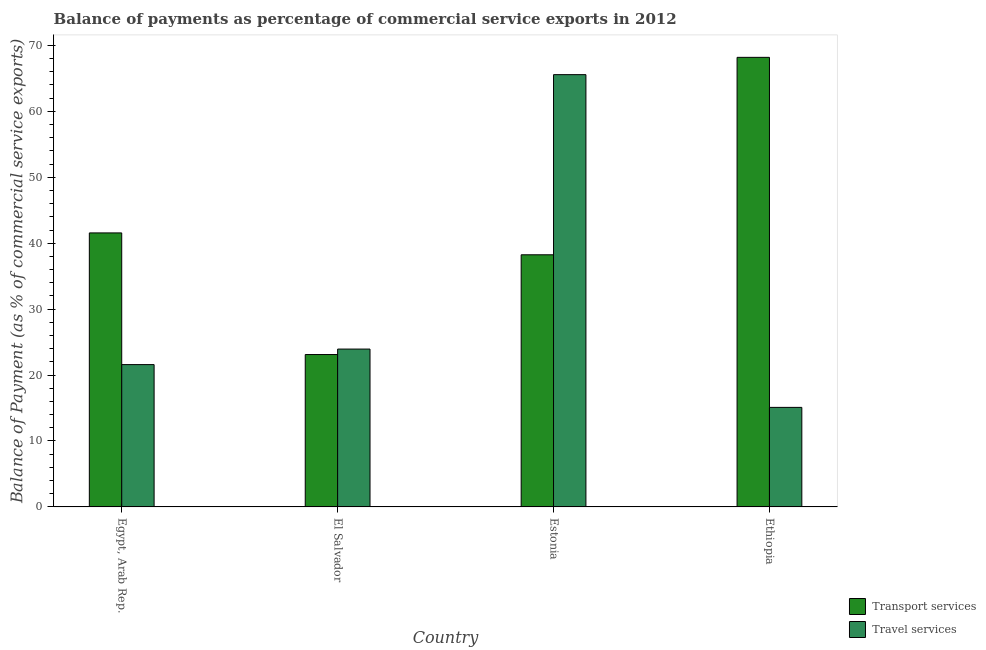How many different coloured bars are there?
Your response must be concise. 2. Are the number of bars on each tick of the X-axis equal?
Your response must be concise. Yes. How many bars are there on the 2nd tick from the left?
Offer a very short reply. 2. What is the label of the 4th group of bars from the left?
Provide a short and direct response. Ethiopia. In how many cases, is the number of bars for a given country not equal to the number of legend labels?
Offer a terse response. 0. What is the balance of payments of travel services in Estonia?
Make the answer very short. 65.56. Across all countries, what is the maximum balance of payments of travel services?
Offer a terse response. 65.56. Across all countries, what is the minimum balance of payments of transport services?
Provide a succinct answer. 23.11. In which country was the balance of payments of travel services maximum?
Your answer should be compact. Estonia. In which country was the balance of payments of travel services minimum?
Provide a short and direct response. Ethiopia. What is the total balance of payments of travel services in the graph?
Your response must be concise. 126.19. What is the difference between the balance of payments of transport services in El Salvador and that in Ethiopia?
Ensure brevity in your answer.  -45.07. What is the difference between the balance of payments of travel services in El Salvador and the balance of payments of transport services in Egypt, Arab Rep.?
Ensure brevity in your answer.  -17.62. What is the average balance of payments of transport services per country?
Provide a succinct answer. 42.77. What is the difference between the balance of payments of transport services and balance of payments of travel services in Estonia?
Your answer should be compact. -27.32. What is the ratio of the balance of payments of transport services in Egypt, Arab Rep. to that in Estonia?
Your answer should be compact. 1.09. Is the balance of payments of travel services in Egypt, Arab Rep. less than that in Estonia?
Give a very brief answer. Yes. What is the difference between the highest and the second highest balance of payments of travel services?
Provide a short and direct response. 41.62. What is the difference between the highest and the lowest balance of payments of transport services?
Make the answer very short. 45.07. What does the 2nd bar from the left in Estonia represents?
Your answer should be very brief. Travel services. What does the 2nd bar from the right in Egypt, Arab Rep. represents?
Provide a succinct answer. Transport services. How many bars are there?
Your answer should be very brief. 8. Are all the bars in the graph horizontal?
Make the answer very short. No. What is the difference between two consecutive major ticks on the Y-axis?
Offer a terse response. 10. Are the values on the major ticks of Y-axis written in scientific E-notation?
Your answer should be compact. No. Does the graph contain any zero values?
Your answer should be very brief. No. Does the graph contain grids?
Make the answer very short. No. How are the legend labels stacked?
Your answer should be compact. Vertical. What is the title of the graph?
Make the answer very short. Balance of payments as percentage of commercial service exports in 2012. What is the label or title of the Y-axis?
Make the answer very short. Balance of Payment (as % of commercial service exports). What is the Balance of Payment (as % of commercial service exports) of Transport services in Egypt, Arab Rep.?
Provide a succinct answer. 41.56. What is the Balance of Payment (as % of commercial service exports) of Travel services in Egypt, Arab Rep.?
Give a very brief answer. 21.59. What is the Balance of Payment (as % of commercial service exports) in Transport services in El Salvador?
Offer a terse response. 23.11. What is the Balance of Payment (as % of commercial service exports) in Travel services in El Salvador?
Provide a succinct answer. 23.94. What is the Balance of Payment (as % of commercial service exports) of Transport services in Estonia?
Offer a terse response. 38.24. What is the Balance of Payment (as % of commercial service exports) in Travel services in Estonia?
Your response must be concise. 65.56. What is the Balance of Payment (as % of commercial service exports) of Transport services in Ethiopia?
Your response must be concise. 68.18. What is the Balance of Payment (as % of commercial service exports) in Travel services in Ethiopia?
Your answer should be very brief. 15.1. Across all countries, what is the maximum Balance of Payment (as % of commercial service exports) in Transport services?
Make the answer very short. 68.18. Across all countries, what is the maximum Balance of Payment (as % of commercial service exports) in Travel services?
Your response must be concise. 65.56. Across all countries, what is the minimum Balance of Payment (as % of commercial service exports) of Transport services?
Keep it short and to the point. 23.11. Across all countries, what is the minimum Balance of Payment (as % of commercial service exports) in Travel services?
Make the answer very short. 15.1. What is the total Balance of Payment (as % of commercial service exports) in Transport services in the graph?
Offer a terse response. 171.1. What is the total Balance of Payment (as % of commercial service exports) of Travel services in the graph?
Offer a terse response. 126.19. What is the difference between the Balance of Payment (as % of commercial service exports) of Transport services in Egypt, Arab Rep. and that in El Salvador?
Provide a short and direct response. 18.45. What is the difference between the Balance of Payment (as % of commercial service exports) in Travel services in Egypt, Arab Rep. and that in El Salvador?
Make the answer very short. -2.35. What is the difference between the Balance of Payment (as % of commercial service exports) of Transport services in Egypt, Arab Rep. and that in Estonia?
Ensure brevity in your answer.  3.32. What is the difference between the Balance of Payment (as % of commercial service exports) of Travel services in Egypt, Arab Rep. and that in Estonia?
Provide a succinct answer. -43.98. What is the difference between the Balance of Payment (as % of commercial service exports) of Transport services in Egypt, Arab Rep. and that in Ethiopia?
Keep it short and to the point. -26.63. What is the difference between the Balance of Payment (as % of commercial service exports) in Travel services in Egypt, Arab Rep. and that in Ethiopia?
Provide a short and direct response. 6.49. What is the difference between the Balance of Payment (as % of commercial service exports) of Transport services in El Salvador and that in Estonia?
Give a very brief answer. -15.13. What is the difference between the Balance of Payment (as % of commercial service exports) in Travel services in El Salvador and that in Estonia?
Your answer should be compact. -41.62. What is the difference between the Balance of Payment (as % of commercial service exports) of Transport services in El Salvador and that in Ethiopia?
Keep it short and to the point. -45.07. What is the difference between the Balance of Payment (as % of commercial service exports) of Travel services in El Salvador and that in Ethiopia?
Ensure brevity in your answer.  8.84. What is the difference between the Balance of Payment (as % of commercial service exports) in Transport services in Estonia and that in Ethiopia?
Your response must be concise. -29.94. What is the difference between the Balance of Payment (as % of commercial service exports) in Travel services in Estonia and that in Ethiopia?
Your answer should be very brief. 50.46. What is the difference between the Balance of Payment (as % of commercial service exports) of Transport services in Egypt, Arab Rep. and the Balance of Payment (as % of commercial service exports) of Travel services in El Salvador?
Make the answer very short. 17.62. What is the difference between the Balance of Payment (as % of commercial service exports) in Transport services in Egypt, Arab Rep. and the Balance of Payment (as % of commercial service exports) in Travel services in Estonia?
Provide a succinct answer. -24. What is the difference between the Balance of Payment (as % of commercial service exports) in Transport services in Egypt, Arab Rep. and the Balance of Payment (as % of commercial service exports) in Travel services in Ethiopia?
Your response must be concise. 26.46. What is the difference between the Balance of Payment (as % of commercial service exports) in Transport services in El Salvador and the Balance of Payment (as % of commercial service exports) in Travel services in Estonia?
Your answer should be very brief. -42.45. What is the difference between the Balance of Payment (as % of commercial service exports) in Transport services in El Salvador and the Balance of Payment (as % of commercial service exports) in Travel services in Ethiopia?
Offer a very short reply. 8.01. What is the difference between the Balance of Payment (as % of commercial service exports) in Transport services in Estonia and the Balance of Payment (as % of commercial service exports) in Travel services in Ethiopia?
Keep it short and to the point. 23.14. What is the average Balance of Payment (as % of commercial service exports) of Transport services per country?
Provide a short and direct response. 42.77. What is the average Balance of Payment (as % of commercial service exports) in Travel services per country?
Make the answer very short. 31.55. What is the difference between the Balance of Payment (as % of commercial service exports) of Transport services and Balance of Payment (as % of commercial service exports) of Travel services in Egypt, Arab Rep.?
Your answer should be very brief. 19.97. What is the difference between the Balance of Payment (as % of commercial service exports) in Transport services and Balance of Payment (as % of commercial service exports) in Travel services in El Salvador?
Your response must be concise. -0.83. What is the difference between the Balance of Payment (as % of commercial service exports) of Transport services and Balance of Payment (as % of commercial service exports) of Travel services in Estonia?
Ensure brevity in your answer.  -27.32. What is the difference between the Balance of Payment (as % of commercial service exports) of Transport services and Balance of Payment (as % of commercial service exports) of Travel services in Ethiopia?
Offer a terse response. 53.09. What is the ratio of the Balance of Payment (as % of commercial service exports) of Transport services in Egypt, Arab Rep. to that in El Salvador?
Your answer should be very brief. 1.8. What is the ratio of the Balance of Payment (as % of commercial service exports) of Travel services in Egypt, Arab Rep. to that in El Salvador?
Ensure brevity in your answer.  0.9. What is the ratio of the Balance of Payment (as % of commercial service exports) in Transport services in Egypt, Arab Rep. to that in Estonia?
Ensure brevity in your answer.  1.09. What is the ratio of the Balance of Payment (as % of commercial service exports) in Travel services in Egypt, Arab Rep. to that in Estonia?
Make the answer very short. 0.33. What is the ratio of the Balance of Payment (as % of commercial service exports) of Transport services in Egypt, Arab Rep. to that in Ethiopia?
Give a very brief answer. 0.61. What is the ratio of the Balance of Payment (as % of commercial service exports) in Travel services in Egypt, Arab Rep. to that in Ethiopia?
Make the answer very short. 1.43. What is the ratio of the Balance of Payment (as % of commercial service exports) in Transport services in El Salvador to that in Estonia?
Your response must be concise. 0.6. What is the ratio of the Balance of Payment (as % of commercial service exports) of Travel services in El Salvador to that in Estonia?
Offer a very short reply. 0.37. What is the ratio of the Balance of Payment (as % of commercial service exports) of Transport services in El Salvador to that in Ethiopia?
Make the answer very short. 0.34. What is the ratio of the Balance of Payment (as % of commercial service exports) of Travel services in El Salvador to that in Ethiopia?
Provide a succinct answer. 1.59. What is the ratio of the Balance of Payment (as % of commercial service exports) of Transport services in Estonia to that in Ethiopia?
Provide a succinct answer. 0.56. What is the ratio of the Balance of Payment (as % of commercial service exports) in Travel services in Estonia to that in Ethiopia?
Provide a short and direct response. 4.34. What is the difference between the highest and the second highest Balance of Payment (as % of commercial service exports) of Transport services?
Keep it short and to the point. 26.63. What is the difference between the highest and the second highest Balance of Payment (as % of commercial service exports) in Travel services?
Make the answer very short. 41.62. What is the difference between the highest and the lowest Balance of Payment (as % of commercial service exports) in Transport services?
Your answer should be compact. 45.07. What is the difference between the highest and the lowest Balance of Payment (as % of commercial service exports) of Travel services?
Provide a succinct answer. 50.46. 